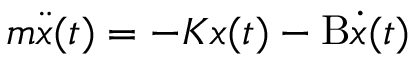<formula> <loc_0><loc_0><loc_500><loc_500>m { \ddot { x } } ( t ) = - K x ( t ) - B { \dot { x } } ( t )</formula> 